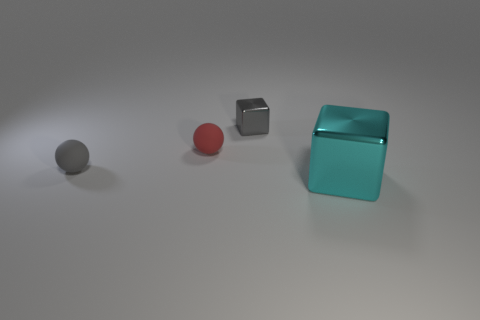How many matte balls are the same color as the tiny metal thing?
Make the answer very short. 1. There is a cube that is left of the big block; what color is it?
Ensure brevity in your answer.  Gray. How many other objects are there of the same color as the big metallic block?
Your answer should be compact. 0. There is a block behind the gray rubber ball; does it have the same size as the red object?
Offer a terse response. Yes. There is a red matte object; what number of tiny red matte objects are in front of it?
Your answer should be compact. 0. Is there a red matte object that has the same size as the gray metallic object?
Your response must be concise. Yes. There is a thing right of the block that is on the left side of the cyan shiny thing; what is its color?
Make the answer very short. Cyan. What number of metallic cubes are on the left side of the big cyan block and in front of the gray rubber object?
Keep it short and to the point. 0. How many gray shiny things have the same shape as the big cyan thing?
Make the answer very short. 1. Does the small red ball have the same material as the cyan object?
Provide a short and direct response. No. 